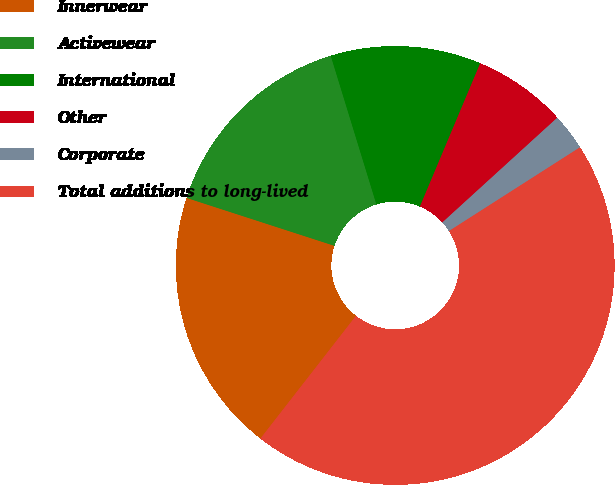Convert chart. <chart><loc_0><loc_0><loc_500><loc_500><pie_chart><fcel>Innerwear<fcel>Activewear<fcel>International<fcel>Other<fcel>Corporate<fcel>Total additions to long-lived<nl><fcel>19.46%<fcel>15.27%<fcel>11.08%<fcel>6.9%<fcel>2.71%<fcel>44.58%<nl></chart> 